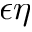<formula> <loc_0><loc_0><loc_500><loc_500>\epsilon \eta</formula> 